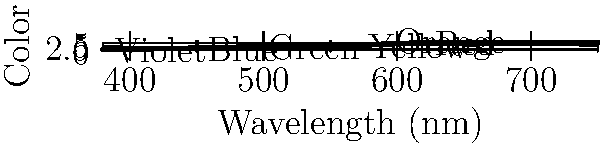As someone who recently had a positive experience with an eye doctor, you've become more interested in how we perceive light. Looking at the spectrum of visible light, which color corresponds to the longest wavelength that the human eye can typically detect? To answer this question, we need to analyze the given spectrum of visible light:

1. The graph shows the relationship between wavelength (in nanometers) and perceived color.
2. The x-axis represents the wavelength, increasing from left to right.
3. The y-axis represents the different colors we perceive.
4. The colors are arranged in the order: Violet, Blue, Green, Yellow, Orange, and Red.
5. The wavelengths increase as we move from Violet to Red.
6. Red has the longest wavelength among the visible colors, at approximately 620-750 nm.
7. Beyond Red, there are longer wavelengths, but they are not visible to the human eye (infrared).

Therefore, among the visible colors, Red corresponds to the longest wavelength that the human eye can typically detect.
Answer: Red 